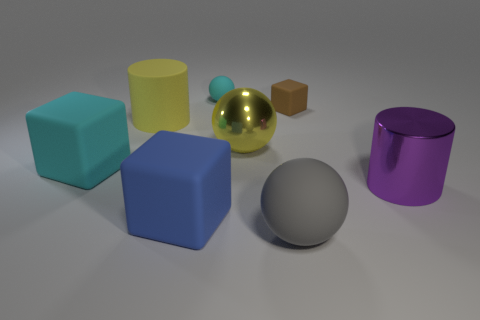There is a thing that is the same color as the metallic sphere; what material is it?
Provide a short and direct response. Rubber. How many rubber things are either purple things or tiny red objects?
Your answer should be very brief. 0. What is the shape of the large gray thing?
Give a very brief answer. Sphere. How many large cylinders have the same material as the purple object?
Your answer should be compact. 0. There is a big cylinder that is made of the same material as the large gray ball; what color is it?
Keep it short and to the point. Yellow. Does the thing to the right of the brown rubber block have the same size as the small cyan ball?
Offer a very short reply. No. What color is the other big metal object that is the same shape as the gray object?
Ensure brevity in your answer.  Yellow. The small matte object left of the large yellow object that is in front of the yellow object that is left of the tiny ball is what shape?
Your answer should be very brief. Sphere. Does the large blue object have the same shape as the gray object?
Give a very brief answer. No. What shape is the big yellow object on the left side of the small thing that is to the left of the tiny brown block?
Offer a terse response. Cylinder. 